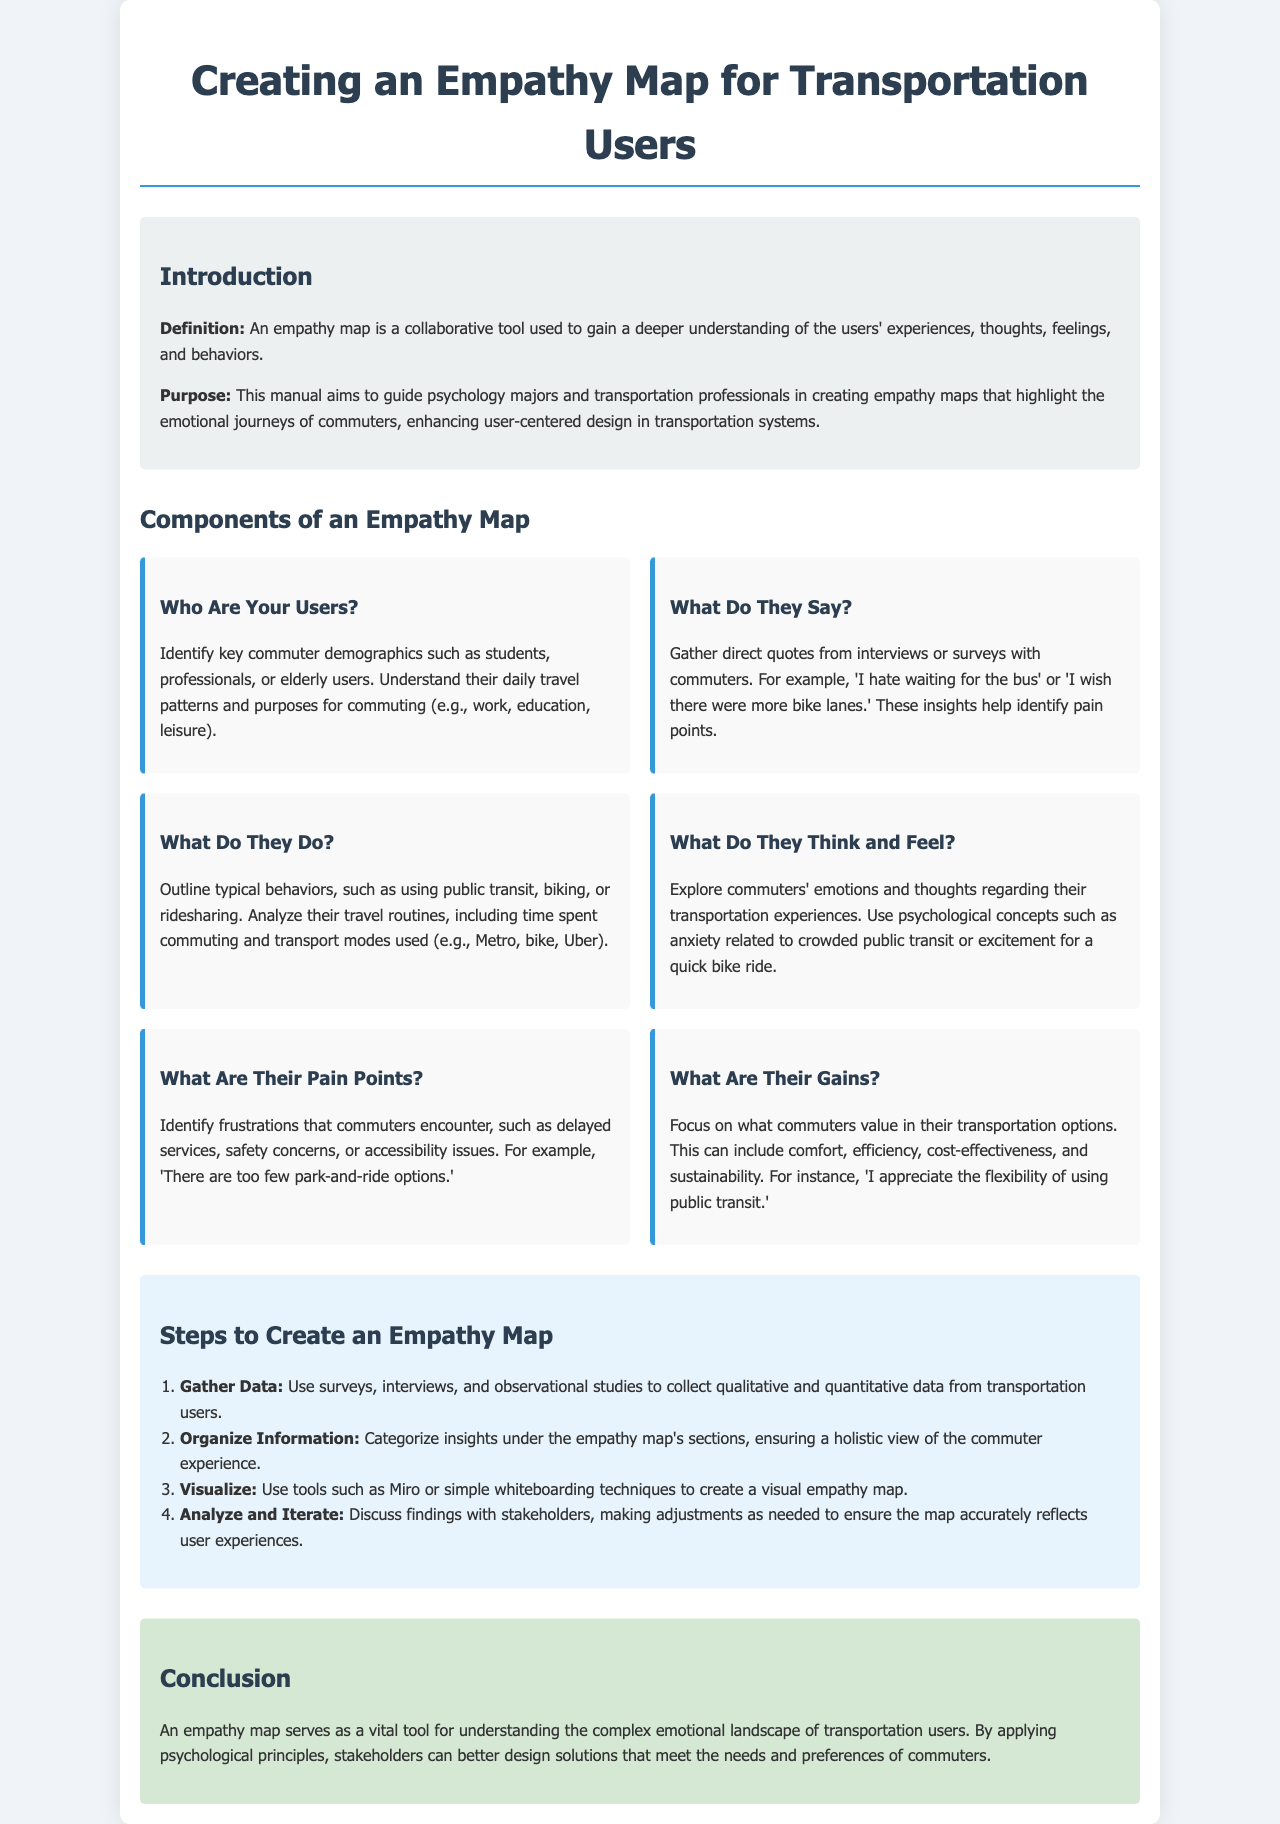What is the purpose of the manual? The purpose is to guide psychology majors and transportation professionals in creating empathy maps that highlight the emotional journeys of commuters.
Answer: To guide psychology majors and transportation professionals How many components are in an empathy map? The document lists six components that make up an empathy map for transportation users.
Answer: Six What do commuters value in their transportation options? The components highlight values such as comfort, efficiency, cost-effectiveness, and sustainability that commuters appreciate.
Answer: Comfort, efficiency, cost-effectiveness, sustainability What is the first step to create an empathy map? The first step in creating an empathy map is to gather qualitative and quantitative data from transportation users.
Answer: Gather Data What type of tool is an empathy map? The document describes an empathy map as a collaborative tool used for understanding users' experiences.
Answer: Collaborative tool How should insights be organized in the empathy map? Insights should be categorized under the empathy map's sections to provide a holistic view of the commuter experience.
Answer: Categorized under sections What psychological concept is mentioned in relation to commuters' emotions? Anxiety related to crowded public transit is mentioned as a psychological concept regarding transportation experiences.
Answer: Anxiety What should be used to visualize the empathy map? The document suggests using tools like Miro or simple whiteboarding techniques for visualization.
Answer: Miro or whiteboarding techniques 